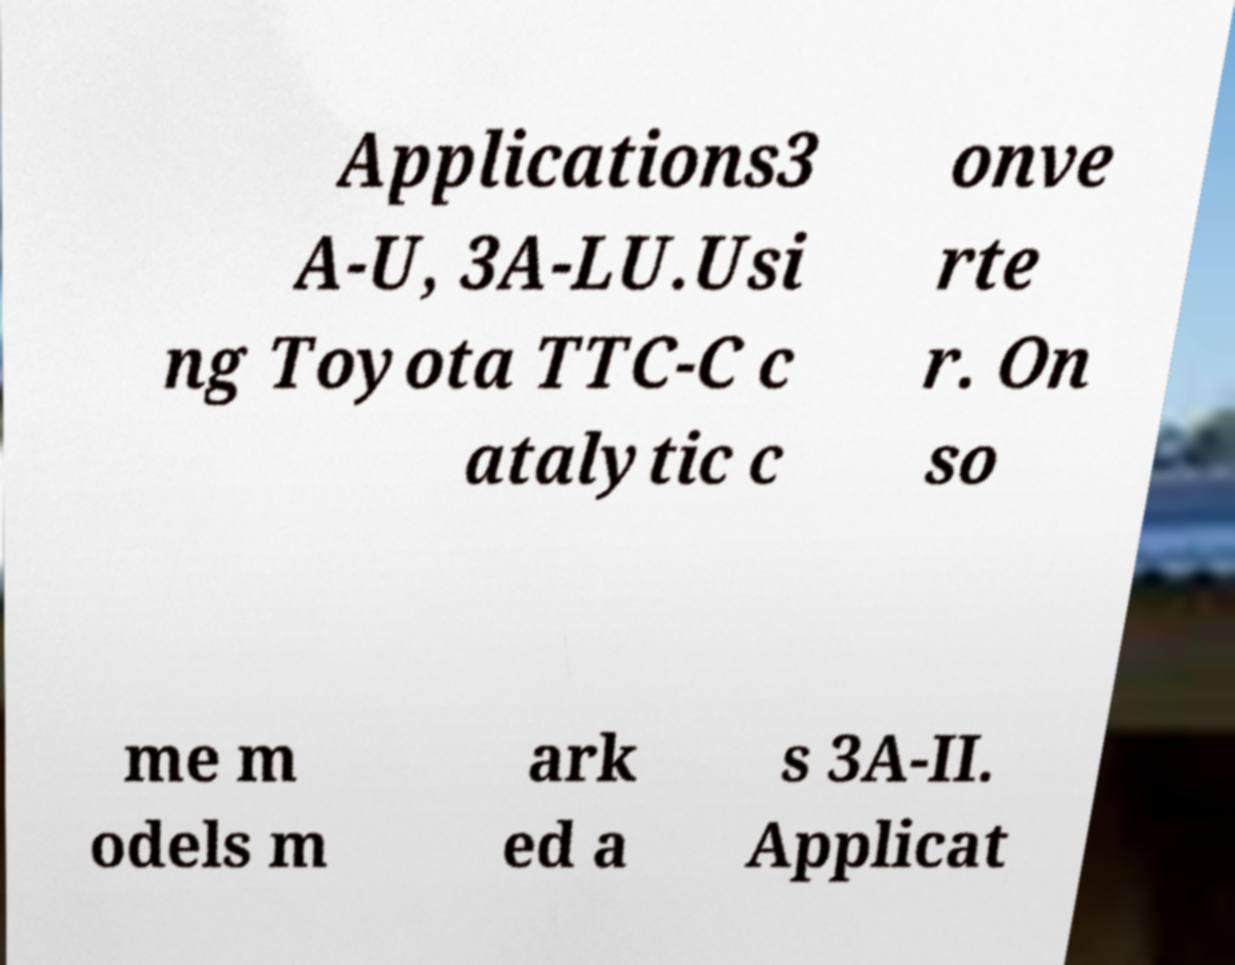There's text embedded in this image that I need extracted. Can you transcribe it verbatim? Applications3 A-U, 3A-LU.Usi ng Toyota TTC-C c atalytic c onve rte r. On so me m odels m ark ed a s 3A-II. Applicat 